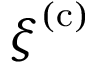Convert formula to latex. <formula><loc_0><loc_0><loc_500><loc_500>{ \xi } ^ { ( c ) }</formula> 